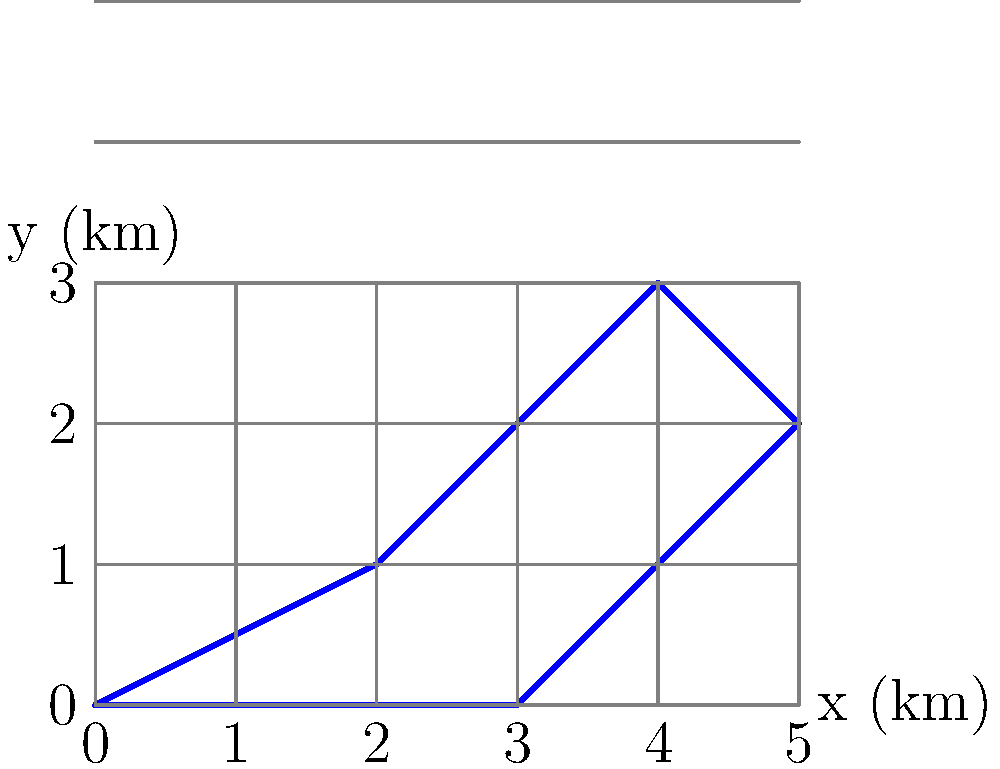A wildlife conservation zone is represented on a topographic map by the irregular blue shape shown above. Each grid square represents 1 square kilometer. Using the trapezoidal rule with 5 vertical strips, calculate the approximate area of the conservation zone in square kilometers. Round your answer to the nearest tenth. To solve this problem using the trapezoidal rule, we'll follow these steps:

1) Divide the shape into 5 vertical strips of equal width.
   Width of each strip = $\frac{5}{5} = 1$ km

2) Measure the height of the shape at each vertical line:
   $y_0 = 0$ km
   $y_1 = 1$ km
   $y_2 = 2$ km
   $y_3 = 3$ km
   $y_4 = 2$ km
   $y_5 = 0$ km

3) Apply the trapezoidal rule formula:
   Area $\approx \frac{h}{2}[f(x_0) + 2f(x_1) + 2f(x_2) + ... + 2f(x_{n-1}) + f(x_n)]$
   
   Where $h$ is the width of each strip, and $f(x_i)$ are the heights.

4) Substituting our values:
   Area $\approx \frac{1}{2}[0 + 2(1) + 2(2) + 2(3) + 2(2) + 0]$
   
5) Simplify:
   Area $\approx \frac{1}{2}[16]$
        $= 8$ square kilometers

Therefore, the approximate area of the conservation zone is 8.0 square kilometers.
Answer: 8.0 km² 